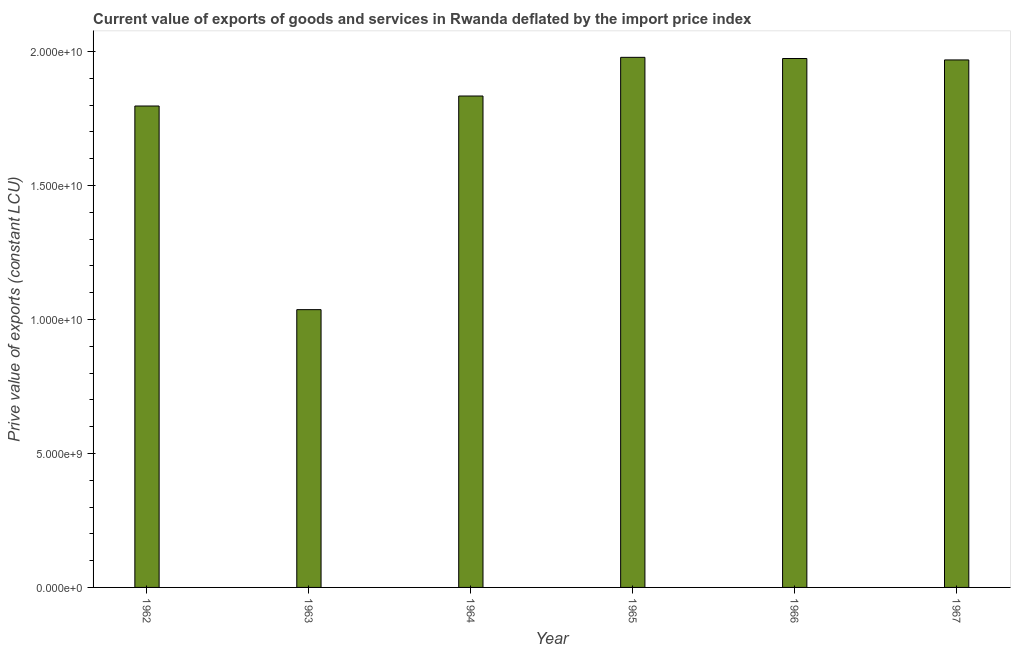Does the graph contain any zero values?
Ensure brevity in your answer.  No. What is the title of the graph?
Ensure brevity in your answer.  Current value of exports of goods and services in Rwanda deflated by the import price index. What is the label or title of the X-axis?
Your answer should be very brief. Year. What is the label or title of the Y-axis?
Provide a short and direct response. Prive value of exports (constant LCU). What is the price value of exports in 1965?
Offer a very short reply. 1.98e+1. Across all years, what is the maximum price value of exports?
Ensure brevity in your answer.  1.98e+1. Across all years, what is the minimum price value of exports?
Make the answer very short. 1.04e+1. In which year was the price value of exports maximum?
Your response must be concise. 1965. In which year was the price value of exports minimum?
Your response must be concise. 1963. What is the sum of the price value of exports?
Make the answer very short. 1.06e+11. What is the difference between the price value of exports in 1965 and 1966?
Provide a short and direct response. 4.39e+07. What is the average price value of exports per year?
Keep it short and to the point. 1.76e+1. What is the median price value of exports?
Your answer should be very brief. 1.90e+1. In how many years, is the price value of exports greater than 17000000000 LCU?
Offer a terse response. 5. Is the price value of exports in 1962 less than that in 1967?
Your response must be concise. Yes. What is the difference between the highest and the second highest price value of exports?
Offer a very short reply. 4.39e+07. What is the difference between the highest and the lowest price value of exports?
Offer a very short reply. 9.42e+09. In how many years, is the price value of exports greater than the average price value of exports taken over all years?
Your answer should be compact. 5. How many years are there in the graph?
Make the answer very short. 6. Are the values on the major ticks of Y-axis written in scientific E-notation?
Offer a terse response. Yes. What is the Prive value of exports (constant LCU) of 1962?
Ensure brevity in your answer.  1.80e+1. What is the Prive value of exports (constant LCU) of 1963?
Keep it short and to the point. 1.04e+1. What is the Prive value of exports (constant LCU) in 1964?
Make the answer very short. 1.83e+1. What is the Prive value of exports (constant LCU) in 1965?
Make the answer very short. 1.98e+1. What is the Prive value of exports (constant LCU) of 1966?
Make the answer very short. 1.97e+1. What is the Prive value of exports (constant LCU) of 1967?
Provide a succinct answer. 1.97e+1. What is the difference between the Prive value of exports (constant LCU) in 1962 and 1963?
Make the answer very short. 7.60e+09. What is the difference between the Prive value of exports (constant LCU) in 1962 and 1964?
Your answer should be compact. -3.73e+08. What is the difference between the Prive value of exports (constant LCU) in 1962 and 1965?
Ensure brevity in your answer.  -1.82e+09. What is the difference between the Prive value of exports (constant LCU) in 1962 and 1966?
Offer a very short reply. -1.77e+09. What is the difference between the Prive value of exports (constant LCU) in 1962 and 1967?
Your answer should be very brief. -1.72e+09. What is the difference between the Prive value of exports (constant LCU) in 1963 and 1964?
Make the answer very short. -7.97e+09. What is the difference between the Prive value of exports (constant LCU) in 1963 and 1965?
Keep it short and to the point. -9.42e+09. What is the difference between the Prive value of exports (constant LCU) in 1963 and 1966?
Offer a terse response. -9.37e+09. What is the difference between the Prive value of exports (constant LCU) in 1963 and 1967?
Give a very brief answer. -9.32e+09. What is the difference between the Prive value of exports (constant LCU) in 1964 and 1965?
Keep it short and to the point. -1.44e+09. What is the difference between the Prive value of exports (constant LCU) in 1964 and 1966?
Make the answer very short. -1.40e+09. What is the difference between the Prive value of exports (constant LCU) in 1964 and 1967?
Your answer should be very brief. -1.35e+09. What is the difference between the Prive value of exports (constant LCU) in 1965 and 1966?
Your answer should be very brief. 4.39e+07. What is the difference between the Prive value of exports (constant LCU) in 1965 and 1967?
Your answer should be compact. 9.72e+07. What is the difference between the Prive value of exports (constant LCU) in 1966 and 1967?
Ensure brevity in your answer.  5.33e+07. What is the ratio of the Prive value of exports (constant LCU) in 1962 to that in 1963?
Provide a succinct answer. 1.73. What is the ratio of the Prive value of exports (constant LCU) in 1962 to that in 1965?
Your response must be concise. 0.91. What is the ratio of the Prive value of exports (constant LCU) in 1962 to that in 1966?
Give a very brief answer. 0.91. What is the ratio of the Prive value of exports (constant LCU) in 1963 to that in 1964?
Make the answer very short. 0.56. What is the ratio of the Prive value of exports (constant LCU) in 1963 to that in 1965?
Provide a succinct answer. 0.52. What is the ratio of the Prive value of exports (constant LCU) in 1963 to that in 1966?
Provide a short and direct response. 0.53. What is the ratio of the Prive value of exports (constant LCU) in 1963 to that in 1967?
Offer a terse response. 0.53. What is the ratio of the Prive value of exports (constant LCU) in 1964 to that in 1965?
Keep it short and to the point. 0.93. What is the ratio of the Prive value of exports (constant LCU) in 1964 to that in 1966?
Your answer should be compact. 0.93. What is the ratio of the Prive value of exports (constant LCU) in 1964 to that in 1967?
Your answer should be compact. 0.93. What is the ratio of the Prive value of exports (constant LCU) in 1965 to that in 1967?
Give a very brief answer. 1. What is the ratio of the Prive value of exports (constant LCU) in 1966 to that in 1967?
Your response must be concise. 1. 